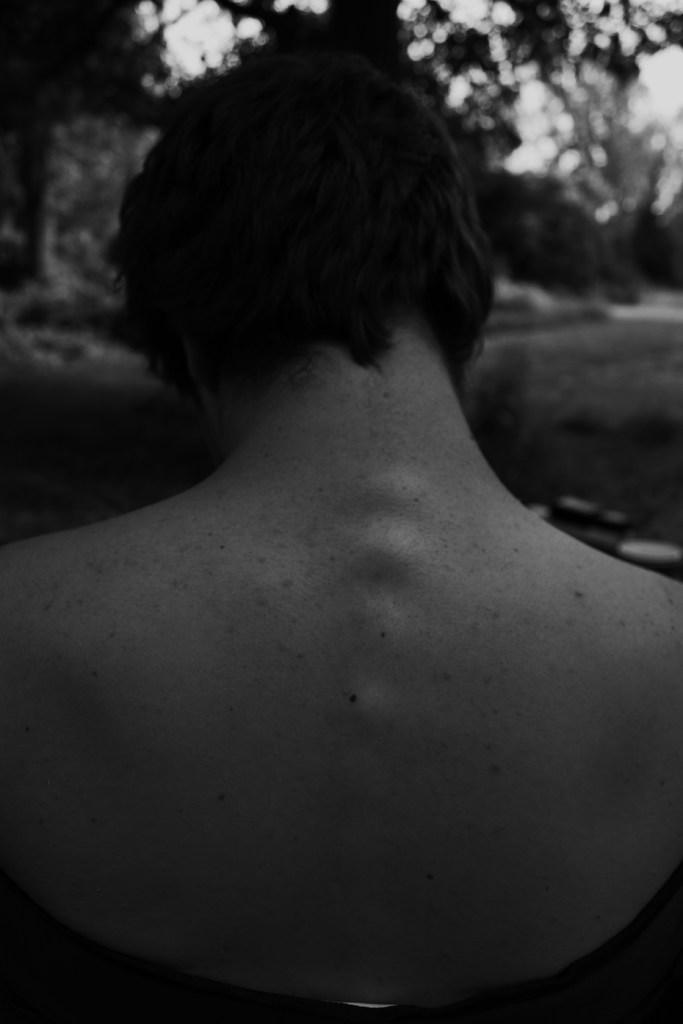Could you give a brief overview of what you see in this image? We can see a black and white image of a person. 